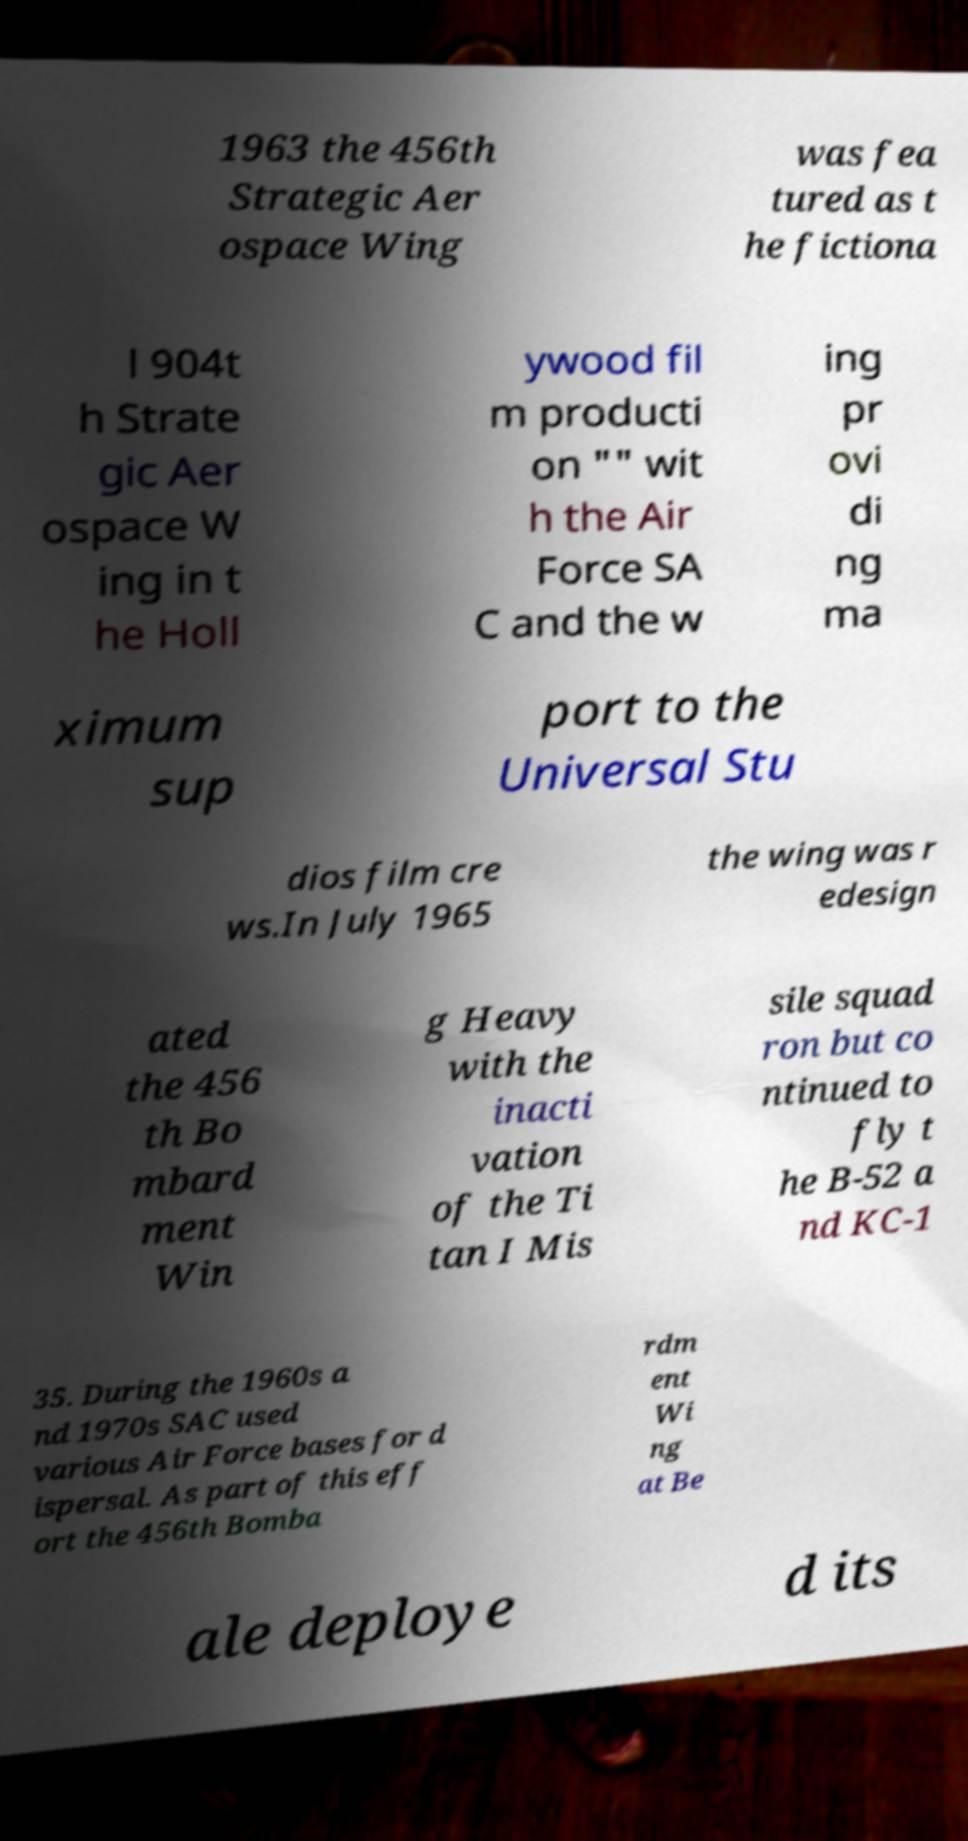Can you read and provide the text displayed in the image?This photo seems to have some interesting text. Can you extract and type it out for me? 1963 the 456th Strategic Aer ospace Wing was fea tured as t he fictiona l 904t h Strate gic Aer ospace W ing in t he Holl ywood fil m producti on "" wit h the Air Force SA C and the w ing pr ovi di ng ma ximum sup port to the Universal Stu dios film cre ws.In July 1965 the wing was r edesign ated the 456 th Bo mbard ment Win g Heavy with the inacti vation of the Ti tan I Mis sile squad ron but co ntinued to fly t he B-52 a nd KC-1 35. During the 1960s a nd 1970s SAC used various Air Force bases for d ispersal. As part of this eff ort the 456th Bomba rdm ent Wi ng at Be ale deploye d its 